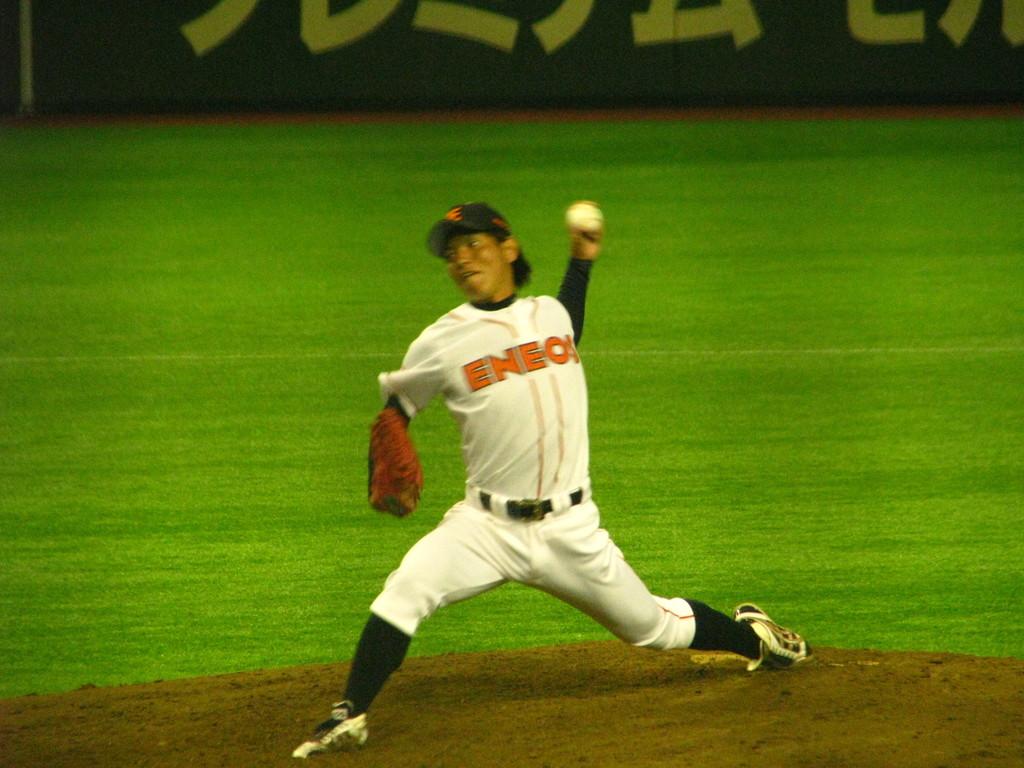What does it say on the guy's shirt?
Give a very brief answer. Eneo. 